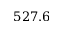Convert formula to latex. <formula><loc_0><loc_0><loc_500><loc_500>5 2 7 . 6</formula> 